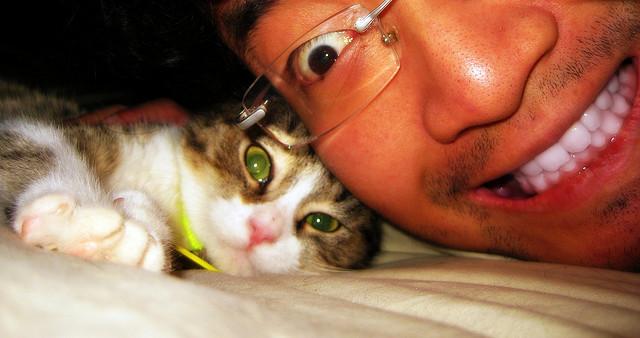Are the cat and the man cuddling?
Give a very brief answer. Yes. Is the cat wearing a collar?
Quick response, please. Yes. Is he crushing the cat?
Quick response, please. No. 